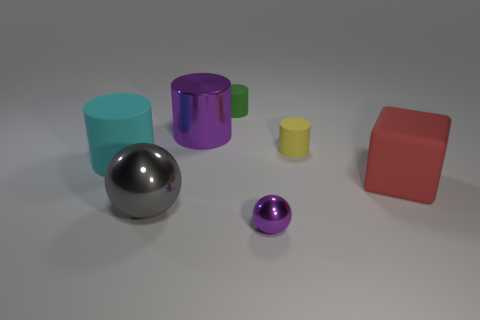There is a thing that is the same color as the large metal cylinder; what shape is it?
Make the answer very short. Sphere. Is the shape of the small object in front of the small yellow rubber thing the same as the big thing in front of the large red object?
Your answer should be compact. Yes. What is the color of the small thing that is the same material as the small green cylinder?
Offer a very short reply. Yellow. Is the size of the purple metal thing that is in front of the big shiny cylinder the same as the purple object that is behind the block?
Ensure brevity in your answer.  No. What shape is the metal thing that is both in front of the red thing and behind the tiny purple ball?
Provide a short and direct response. Sphere. Are there any tiny green objects made of the same material as the small yellow cylinder?
Ensure brevity in your answer.  Yes. There is a thing that is the same color as the tiny sphere; what is its material?
Provide a succinct answer. Metal. Is the material of the tiny purple object that is in front of the gray sphere the same as the big thing that is on the right side of the small green thing?
Ensure brevity in your answer.  No. Is the number of objects greater than the number of red rubber cubes?
Provide a succinct answer. Yes. The tiny object to the right of the metal thing right of the large metal object that is behind the gray ball is what color?
Make the answer very short. Yellow. 